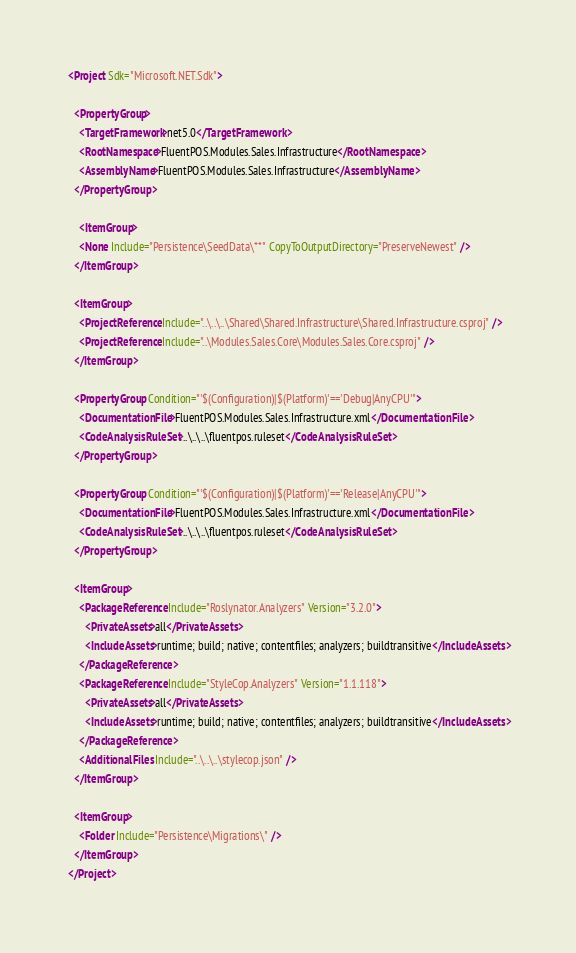<code> <loc_0><loc_0><loc_500><loc_500><_XML_><Project Sdk="Microsoft.NET.Sdk">

  <PropertyGroup>
    <TargetFramework>net5.0</TargetFramework>
    <RootNamespace>FluentPOS.Modules.Sales.Infrastructure</RootNamespace>
    <AssemblyName>FluentPOS.Modules.Sales.Infrastructure</AssemblyName>
  </PropertyGroup>

    <ItemGroup>
    <None Include="Persistence\SeedData\**" CopyToOutputDirectory="PreserveNewest" />
  </ItemGroup>
  
  <ItemGroup>
    <ProjectReference Include="..\..\..\Shared\Shared.Infrastructure\Shared.Infrastructure.csproj" />
    <ProjectReference Include="..\Modules.Sales.Core\Modules.Sales.Core.csproj" />
  </ItemGroup>
  
  <PropertyGroup Condition="'$(Configuration)|$(Platform)'=='Debug|AnyCPU'">
    <DocumentationFile>FluentPOS.Modules.Sales.Infrastructure.xml</DocumentationFile>
    <CodeAnalysisRuleSet>..\..\..\fluentpos.ruleset</CodeAnalysisRuleSet>
  </PropertyGroup>

  <PropertyGroup Condition="'$(Configuration)|$(Platform)'=='Release|AnyCPU'">
    <DocumentationFile>FluentPOS.Modules.Sales.Infrastructure.xml</DocumentationFile>
    <CodeAnalysisRuleSet>..\..\..\fluentpos.ruleset</CodeAnalysisRuleSet>
  </PropertyGroup>

  <ItemGroup>
    <PackageReference Include="Roslynator.Analyzers" Version="3.2.0">
      <PrivateAssets>all</PrivateAssets>
      <IncludeAssets>runtime; build; native; contentfiles; analyzers; buildtransitive</IncludeAssets>
    </PackageReference>
    <PackageReference Include="StyleCop.Analyzers" Version="1.1.118">
      <PrivateAssets>all</PrivateAssets>
      <IncludeAssets>runtime; build; native; contentfiles; analyzers; buildtransitive</IncludeAssets>
    </PackageReference>
    <AdditionalFiles Include="..\..\..\stylecop.json" />
  </ItemGroup>

  <ItemGroup>
    <Folder Include="Persistence\Migrations\" />
  </ItemGroup>
</Project>
</code> 